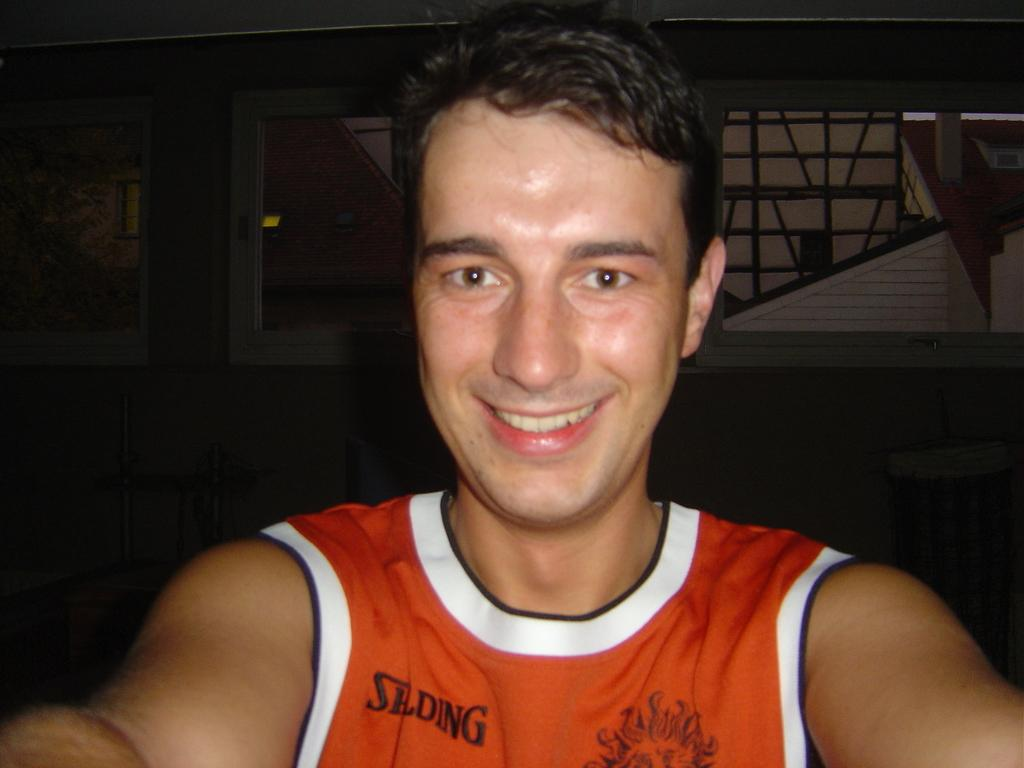<image>
Provide a brief description of the given image. The guy is taking a selfie with a Spalding jersey on. 